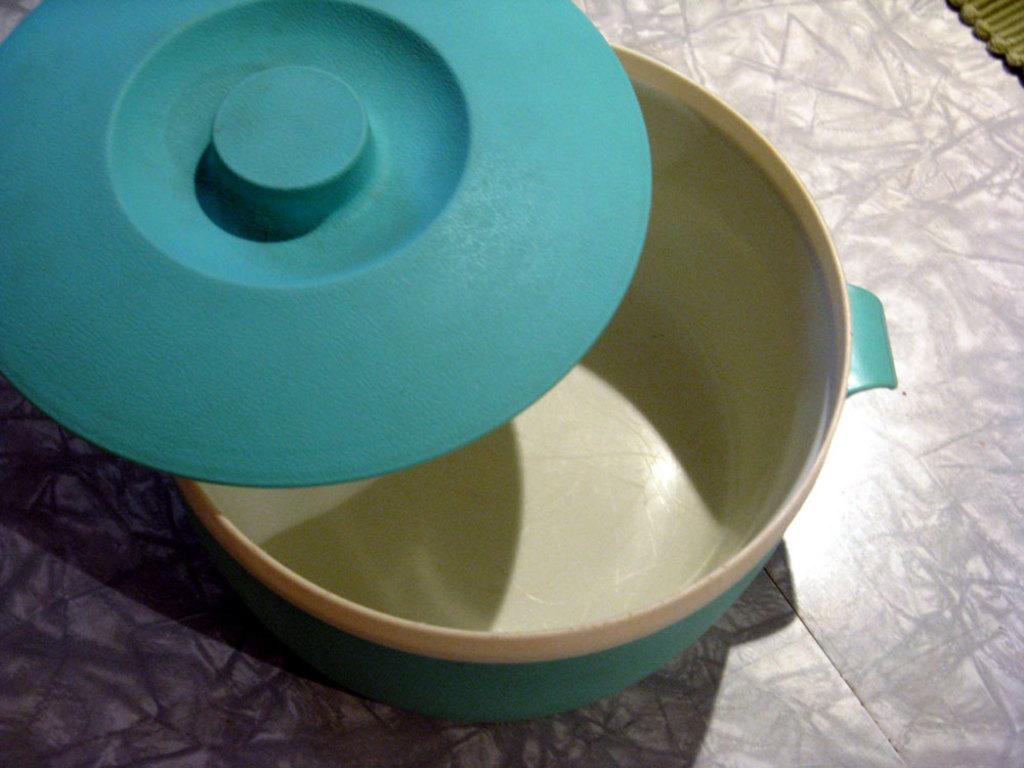Can you describe this image briefly? In this picture, we see a bowl and the lid in blue color. This bowl looks like a hot box. At the bottom, we see the floor. 